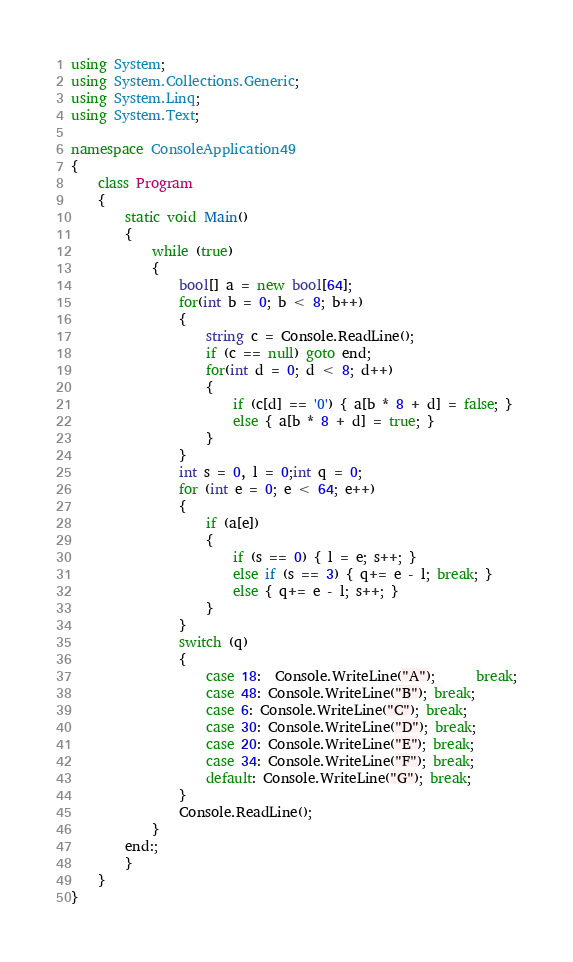Convert code to text. <code><loc_0><loc_0><loc_500><loc_500><_C#_>using System;
using System.Collections.Generic;
using System.Linq;
using System.Text;

namespace ConsoleApplication49
{
    class Program
    {
        static void Main()
        {
            while (true)
            {
                bool[] a = new bool[64];
                for(int b = 0; b < 8; b++)
                {
                    string c = Console.ReadLine();
                    if (c == null) goto end; 
                    for(int d = 0; d < 8; d++)
                    {
                        if (c[d] == '0') { a[b * 8 + d] = false; }
                        else { a[b * 8 + d] = true; }
                    }
                }
                int s = 0, l = 0;int q = 0;
                for (int e = 0; e < 64; e++)
                {
                    if (a[e])
                    {
                        if (s == 0) { l = e; s++; }
                        else if (s == 3) { q+= e - l; break; }
                        else { q+= e - l; s++; }
                    }
                }
                switch (q)
                {
                    case 18:  Console.WriteLine("A");      break;
                    case 48: Console.WriteLine("B"); break;
                    case 6: Console.WriteLine("C"); break;
                    case 30: Console.WriteLine("D"); break;
                    case 20: Console.WriteLine("E"); break;
                    case 34: Console.WriteLine("F"); break;
                    default: Console.WriteLine("G"); break;
                }
                Console.ReadLine();
            }
        end:;
        }
    }
}</code> 